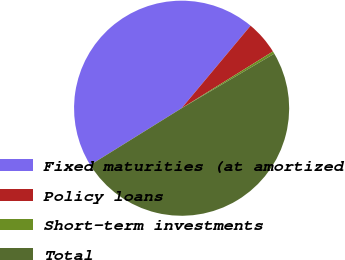Convert chart. <chart><loc_0><loc_0><loc_500><loc_500><pie_chart><fcel>Fixed maturities (at amortized<fcel>Policy loans<fcel>Short-term investments<fcel>Total<nl><fcel>44.93%<fcel>5.07%<fcel>0.38%<fcel>49.62%<nl></chart> 